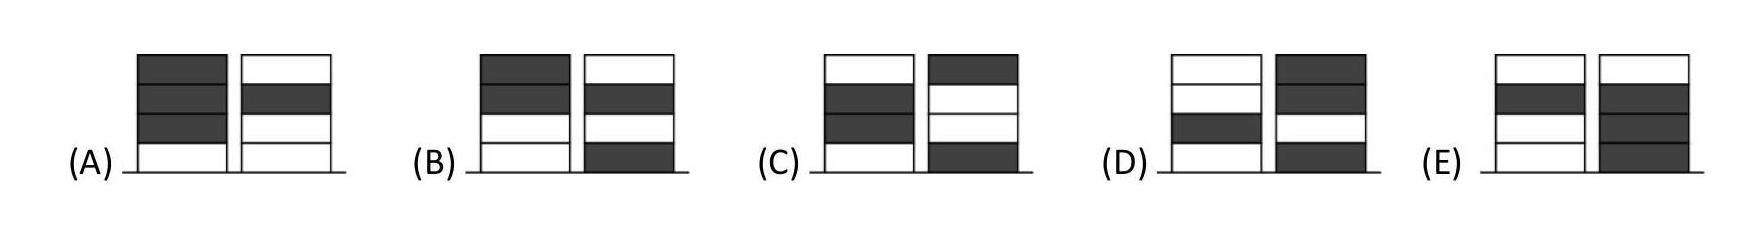Ronja had four white tokens and Wanja had four grey tokens. They played a game in which they took turns to place one of their tokens to create two piles. Ronja placed her first token first. Which pair of piles could they not create? The correct answer is 'E'. In this option, both piles consist of an even number of tokens, which is not possible if they are taking turns placing them. Since Ronja starts, the sequence would involve an odd number of moves for her, ending with a white token, leaving an odd total of white tokens in one pile. Options A, B, C, and D all reflect scenarios where one pile has a majority of one color, aligning with possible sequences of their gameplay. 